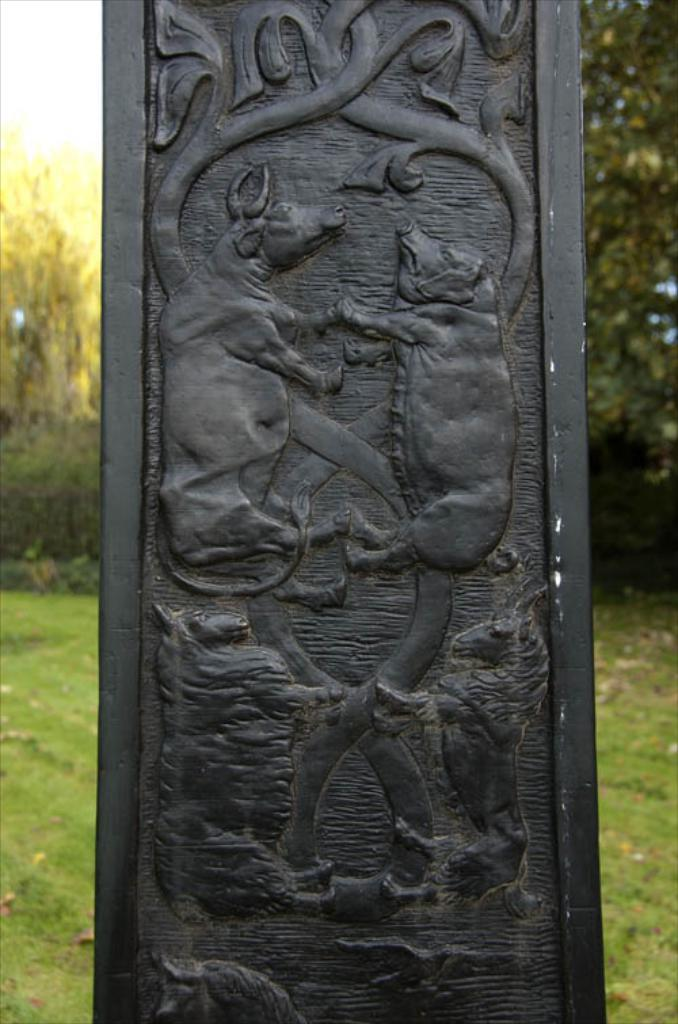What is the color of the pillar in the image? The pillar in the image is black. What is depicted on the pillar? There are arts on the pillar. What type of surface is visible in the image? There is a grass surface visible in the image. What type of vegetation is present on the grass surface? There are trees on the grass surface. How many leaves can be seen on the table in the image? There is no table present in the image, so it is not possible to determine the number of leaves on it. 